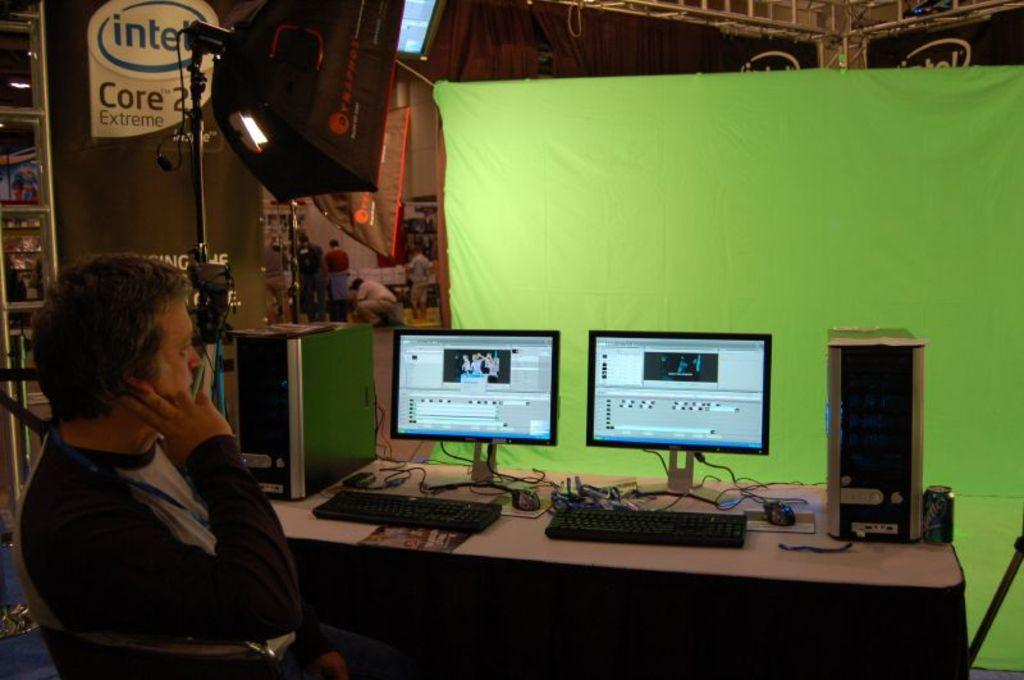<image>
Offer a succinct explanation of the picture presented. A man sits near an Intel Core 2 Extreme ad while looking at two computer monitors. 